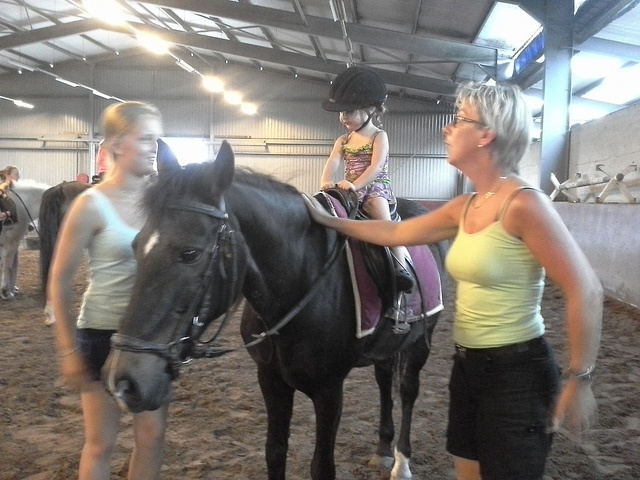Describe the objects in this image and their specific colors. I can see horse in darkgray, black, and gray tones, people in darkgray, black, and gray tones, people in darkgray, gray, and tan tones, people in darkgray, tan, lightgray, and gray tones, and horse in darkgray, gray, white, and black tones in this image. 